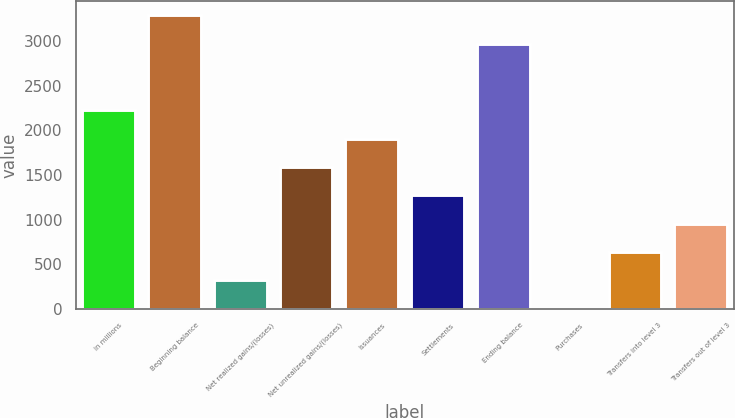Convert chart to OTSL. <chart><loc_0><loc_0><loc_500><loc_500><bar_chart><fcel>in millions<fcel>Beginning balance<fcel>Net realized gains/(losses)<fcel>Net unrealized gains/(losses)<fcel>Issuances<fcel>Settlements<fcel>Ending balance<fcel>Purchases<fcel>Transfers into level 3<fcel>Transfers out of level 3<nl><fcel>2222<fcel>3285<fcel>320<fcel>1588<fcel>1905<fcel>1271<fcel>2968<fcel>3<fcel>637<fcel>954<nl></chart> 